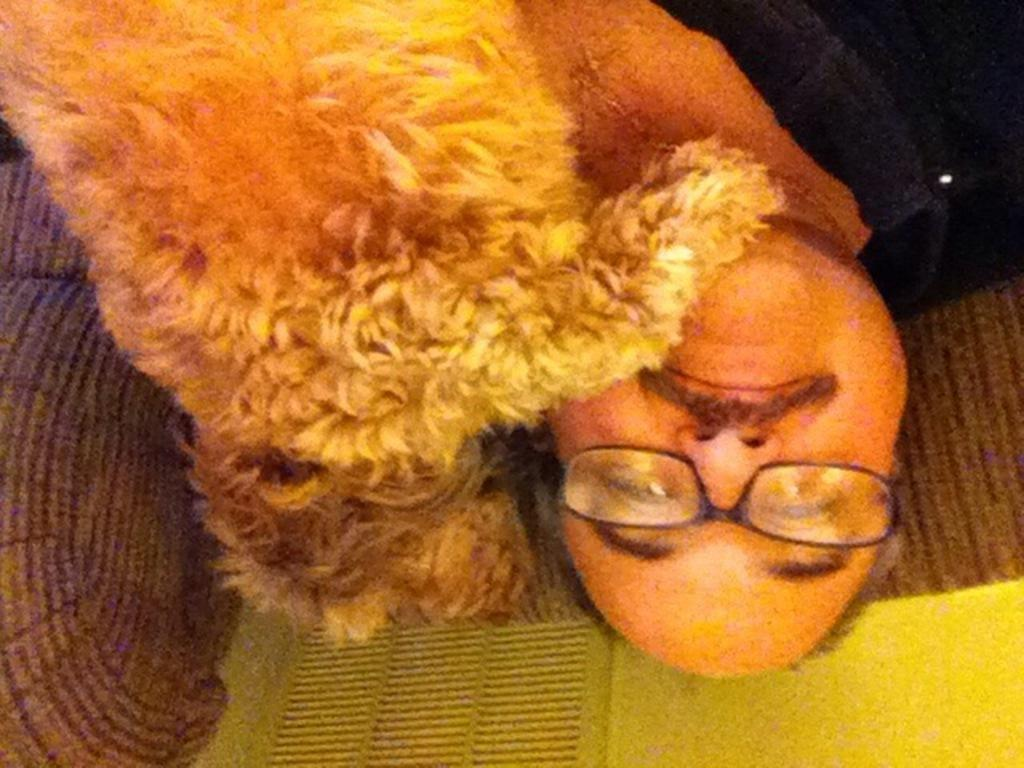What is the person in the image doing? The person is sitting on the sofa. Is there any other living creature in the image? Yes, there is a dog beside the person. What can be seen in the background of the image? There is a wall in the background of the image. What is the price of the cub in the image? There is no cub present in the image, so it is not possible to determine its price. 